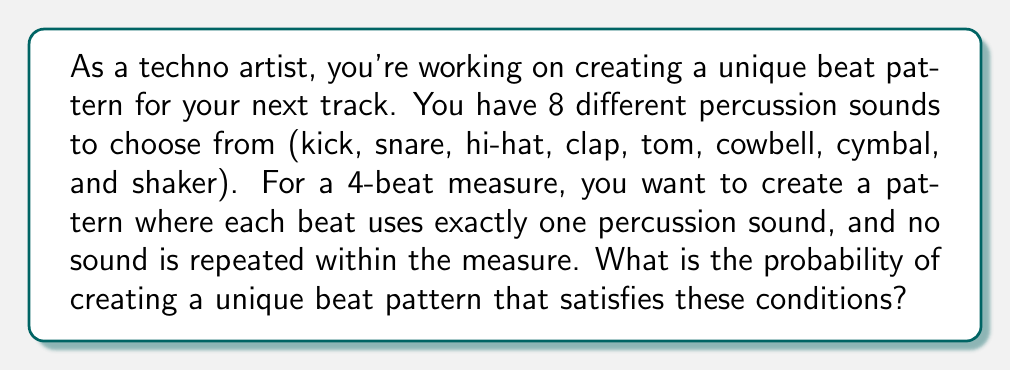Show me your answer to this math problem. Let's approach this step-by-step:

1) First, we need to understand that this is a permutation problem. We are selecting 4 sounds out of 8, where the order matters (as it's a beat pattern) and repetition is not allowed.

2) This scenario can be represented mathematically as a permutation: $P(8,4)$

3) The formula for permutation is:

   $$P(n,r) = \frac{n!}{(n-r)!}$$

   Where $n$ is the total number of items to choose from, and $r$ is the number of items being chosen.

4) In this case, $n = 8$ (total percussion sounds) and $r = 4$ (beats in the measure)

5) Substituting these values:

   $$P(8,4) = \frac{8!}{(8-4)!} = \frac{8!}{4!}$$

6) Calculating this:
   
   $$\frac{8!}{4!} = \frac{8 * 7 * 6 * 5 * 4!}{4!} = 8 * 7 * 6 * 5 = 1680$$

7) This means there are 1680 possible unique beat patterns that satisfy our conditions.

8) To find the probability, we need to consider the total number of possible beat patterns when choosing any of the 8 sounds for each of the 4 beats, which is $8^4 = 4096$.

9) The probability is therefore:

   $$P(\text{unique pattern}) = \frac{\text{favorable outcomes}}{\text{total outcomes}} = \frac{1680}{4096} = \frac{105}{256} \approx 0.4102$$
Answer: The probability of creating a unique beat pattern under these conditions is $\frac{105}{256}$ or approximately 0.4102 (41.02%). 